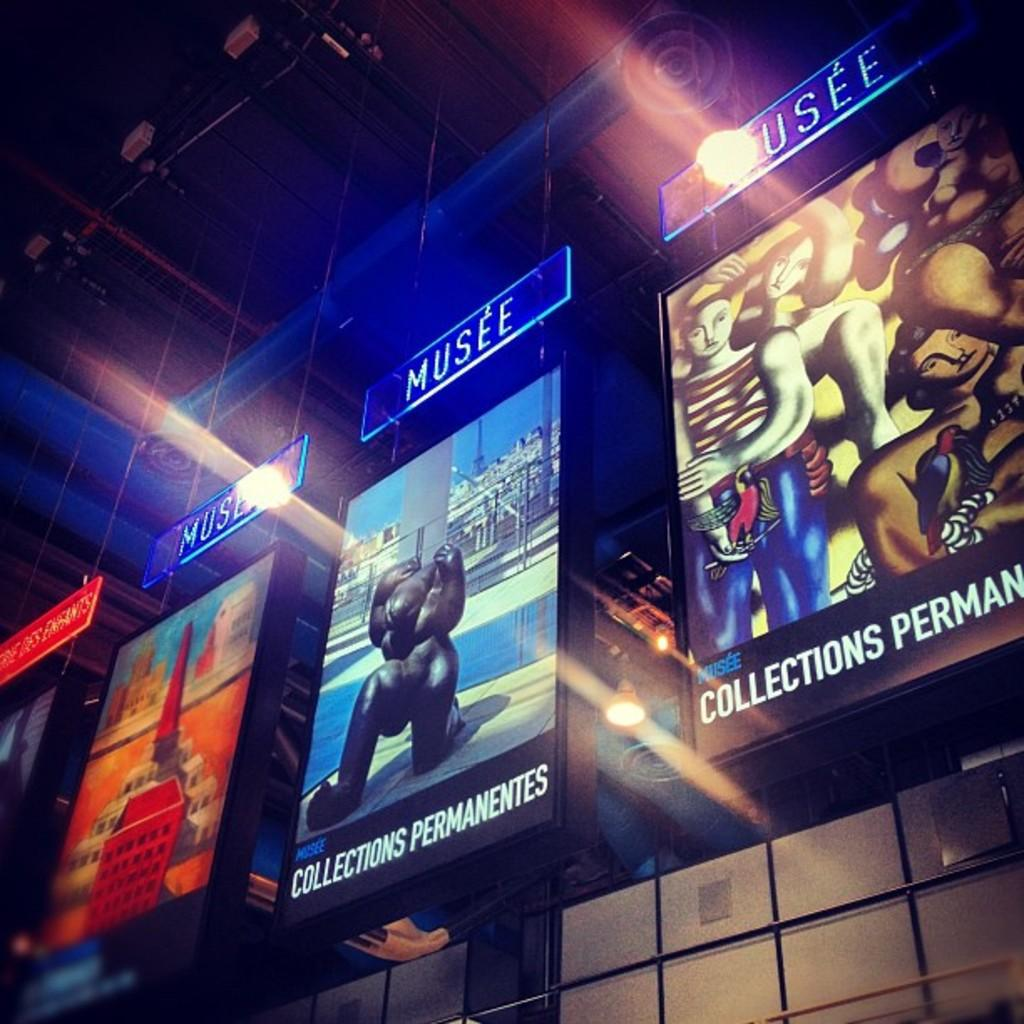<image>
Offer a succinct explanation of the picture presented. lit up signs for Musee for the Collections Permanentes 